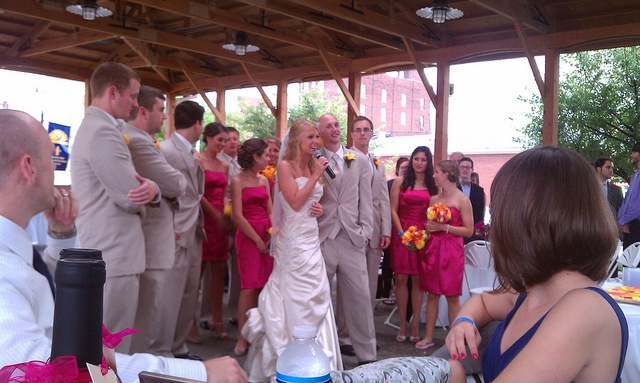Describe the objects in this image and their specific colors. I can see people in maroon, black, darkgray, and gray tones, people in maroon, black, brown, and purple tones, people in maroon, lavender, gray, and darkgray tones, people in maroon, darkgray, gray, and brown tones, and people in maroon, darkgray, brown, and lavender tones in this image. 